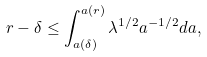Convert formula to latex. <formula><loc_0><loc_0><loc_500><loc_500>r - \delta \leq \int _ { a ( \delta ) } ^ { a ( r ) } \lambda ^ { 1 / 2 } a ^ { - 1 / 2 } d a ,</formula> 